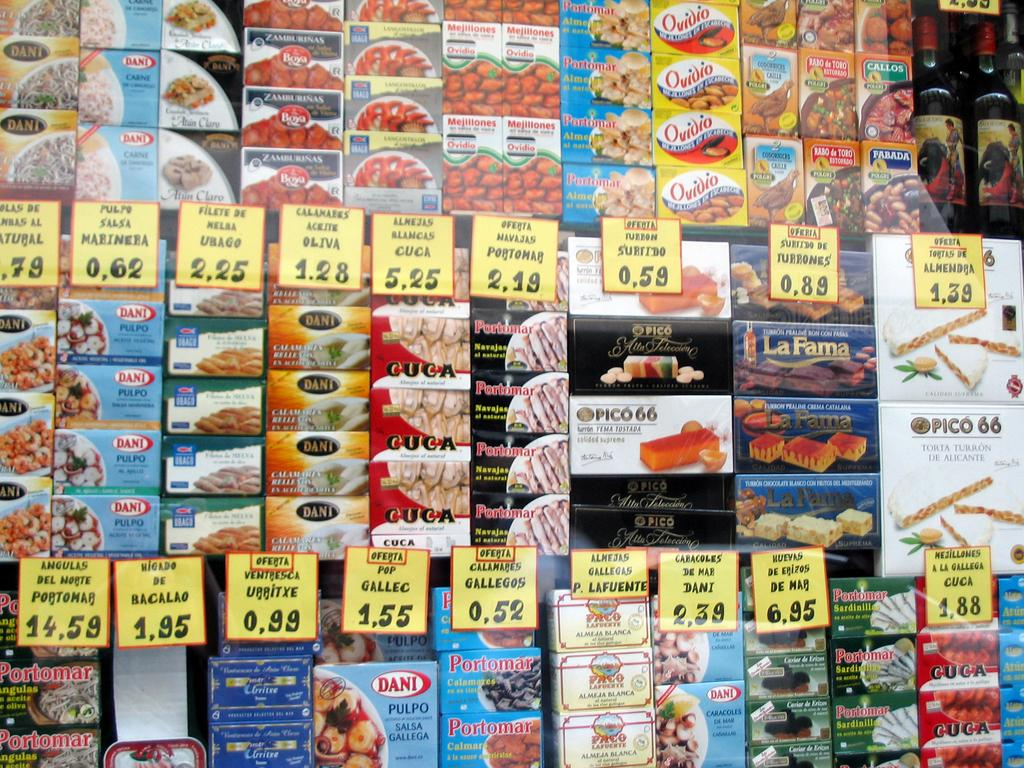Provide a one-sentence caption for the provided image. Various snacks on grocery shelves with the most expensive snack costing 14,59. 